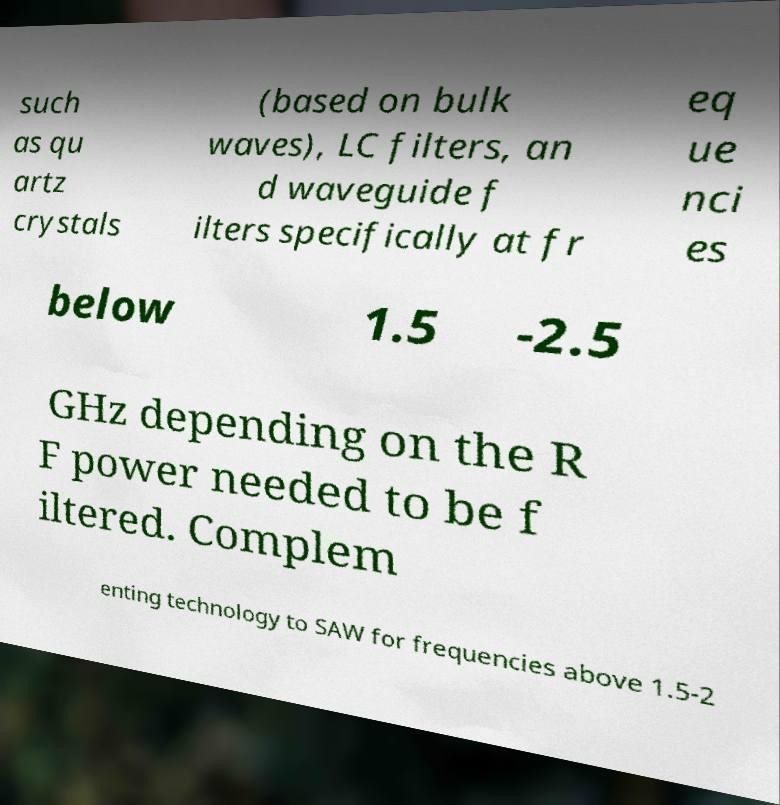Can you read and provide the text displayed in the image?This photo seems to have some interesting text. Can you extract and type it out for me? such as qu artz crystals (based on bulk waves), LC filters, an d waveguide f ilters specifically at fr eq ue nci es below 1.5 -2.5 GHz depending on the R F power needed to be f iltered. Complem enting technology to SAW for frequencies above 1.5-2 